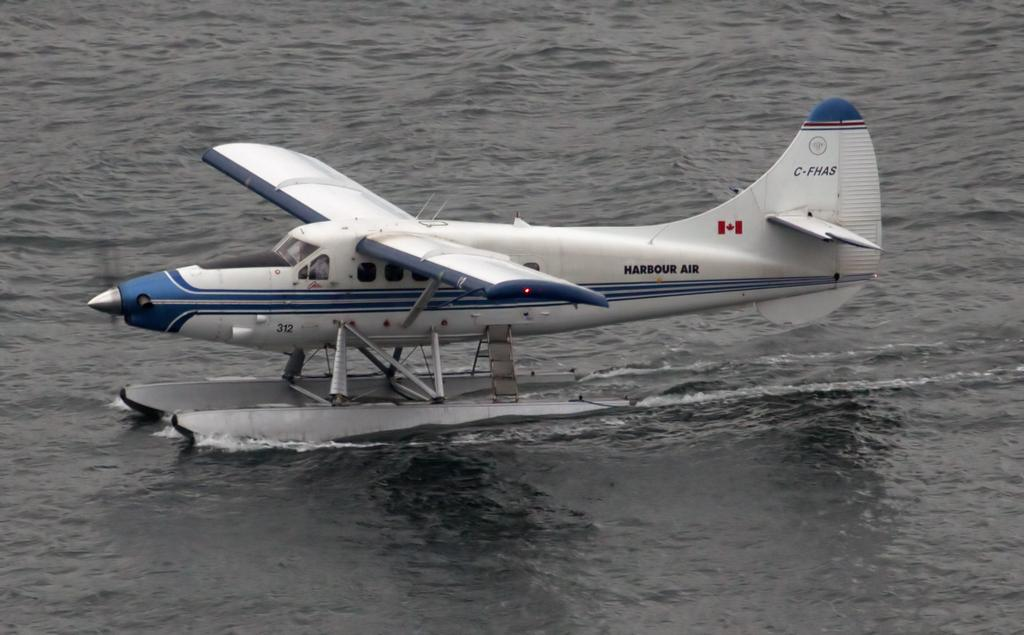What is the main subject of the image? The main subject of the image is an aircraft. Where is the aircraft located in the image? The aircraft is on the water surface in the image. What type of canvas is being used to paint the aircraft in the image? There is no canvas or painting activity present in the image; it is a photograph of an aircraft on the water surface. What type of teeth can be seen in the image? There are no teeth visible in the image, as it features an aircraft on the water surface and teeth are not related to this subject matter. 